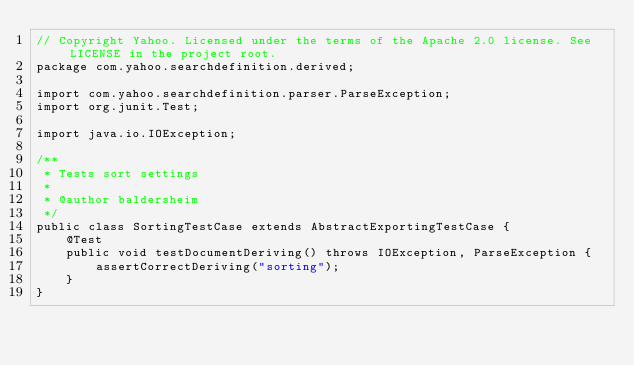<code> <loc_0><loc_0><loc_500><loc_500><_Java_>// Copyright Yahoo. Licensed under the terms of the Apache 2.0 license. See LICENSE in the project root.
package com.yahoo.searchdefinition.derived;

import com.yahoo.searchdefinition.parser.ParseException;
import org.junit.Test;

import java.io.IOException;

/**
 * Tests sort settings
 *
 * @author baldersheim
 */
public class SortingTestCase extends AbstractExportingTestCase {
    @Test
    public void testDocumentDeriving() throws IOException, ParseException {
        assertCorrectDeriving("sorting");
    }
}
</code> 